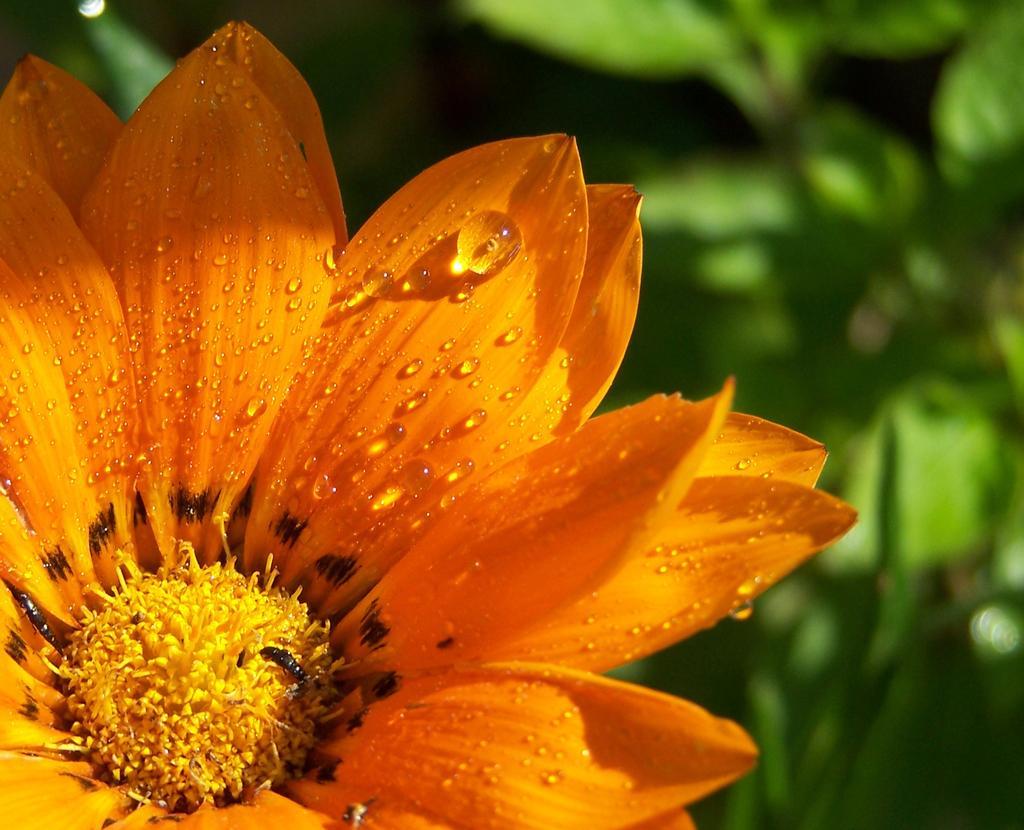In one or two sentences, can you explain what this image depicts? In this picture we can see a flower and in the background we can see leaves and it is blurry. 